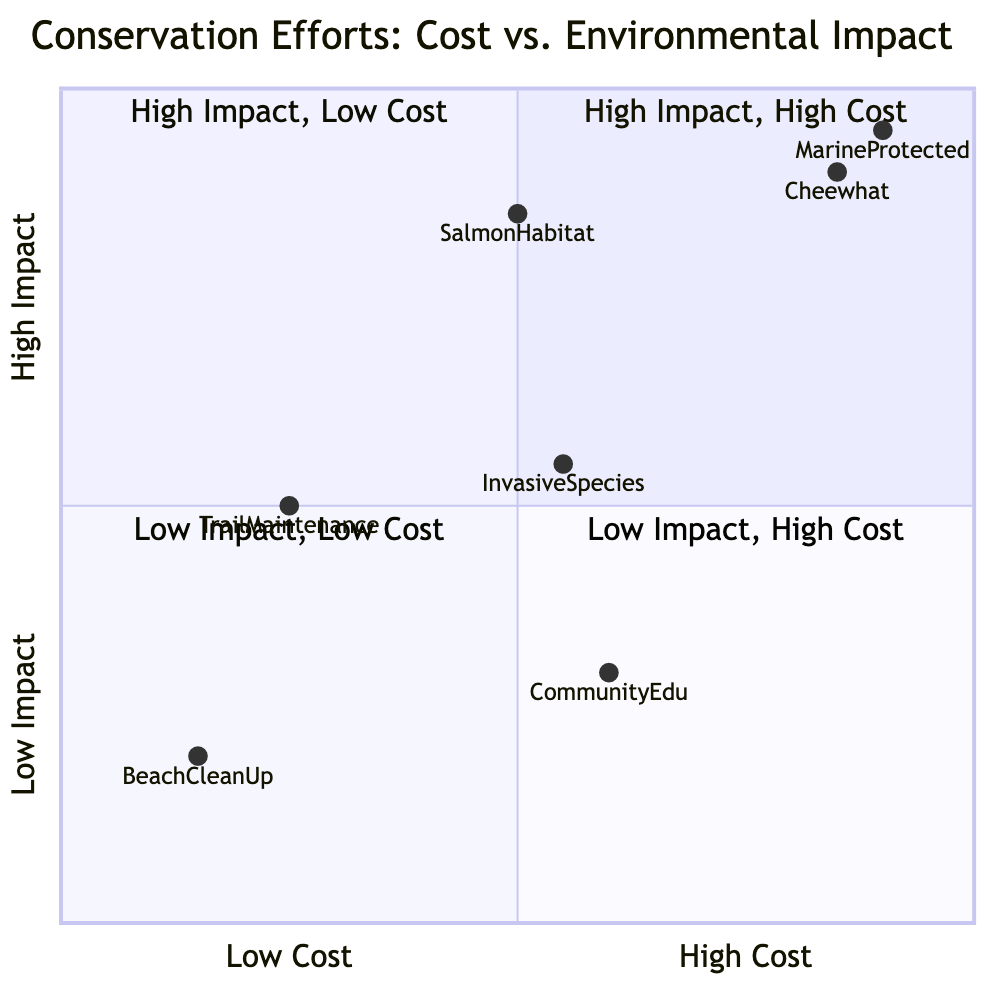What is the highest environmental impact effort in the diagram? The highest environmental impact efforts can be found in the first quadrant, which includes the "Rehabilitation of Cheewhat Giant Area" and "Establishing Marine Protected Areas". Both are placed high on the y-axis. Since both are considered equal in terms of impact, the answer would include both efforts.
Answer: Rehabilitation of Cheewhat Giant Area, Establishing Marine Protected Areas Which conservation effort has the lowest cost? Reviewing the x-axis, the "Beach Clean-Up Volunteer Programs" and "Trail Maintenance and Erosion Control" have the lowest cost designation, which is categorized as "Low". Among them, "Beach Clean-Up Volunteer Programs" is the further left on the x-axis.
Answer: Beach Clean-Up Volunteer Programs How many conservation efforts are categorized as high impact? By examining the y-values of all efforts, the ones in the high impact category (above the midpoint) include "Rehabilitation of Cheewhat Giant Area", "Salmon Habitat Restoration in Kennedy River", and "Establishing Marine Protected Areas". This totals three efforts classified as high impact.
Answer: 3 What is the environmental impact of "Community Education and Outreach"? Looking at the y-value for "Community Education and Outreach", it is positioned toward the lower end of the y-axis, indicating its environmental impact is classified as "Low" based on the diagram.
Answer: Low Which conservation effort has the highest cost according to the diagram? The efforts categorized as having "High" costs are "Rehabilitation of Cheewhat Giant Area" and "Establishing Marine Protected Areas". Both efforts are positioned near the top of the x-axis indicating high expense, but since they share the same cost classification, both are considered.
Answer: Rehabilitation of Cheewhat Giant Area, Establishing Marine Protected Areas Which conservation effort falls in the low impact, low cost quadrant? The efforts that fall into the low impact, low cost quadrant are isolated at the bottom left of the diagram where both axes are low. In this quadrant, "Beach Clean-Up Volunteer Programs" is the clear representative effort.
Answer: Beach Clean-Up Volunteer Programs What percentage of efforts is classified as medium impact? Count the number of conservation efforts placed between the low and high impact zones. The medium impact efforts include "Trail Maintenance and Erosion Control", "Invasive Species Control", and "Community Education and Outreach". Thus, there are three efforts classified as medium, out of a total of seven efforts represented in the diagram. This represents approximately 42.86% of the efforts.
Answer: 42.86% In which quadrant would you place "Salmon Habitat Restoration in Kennedy River"? By locating this effort on the quadrant chart, examine its cost and impact. "Salmon Habitat Restoration in Kennedy River" is indicated as having a medium cost and high environmental impact, which means it falls into quadrant two, where there are high impacts but low costs indicated.
Answer: Quadrant 2 